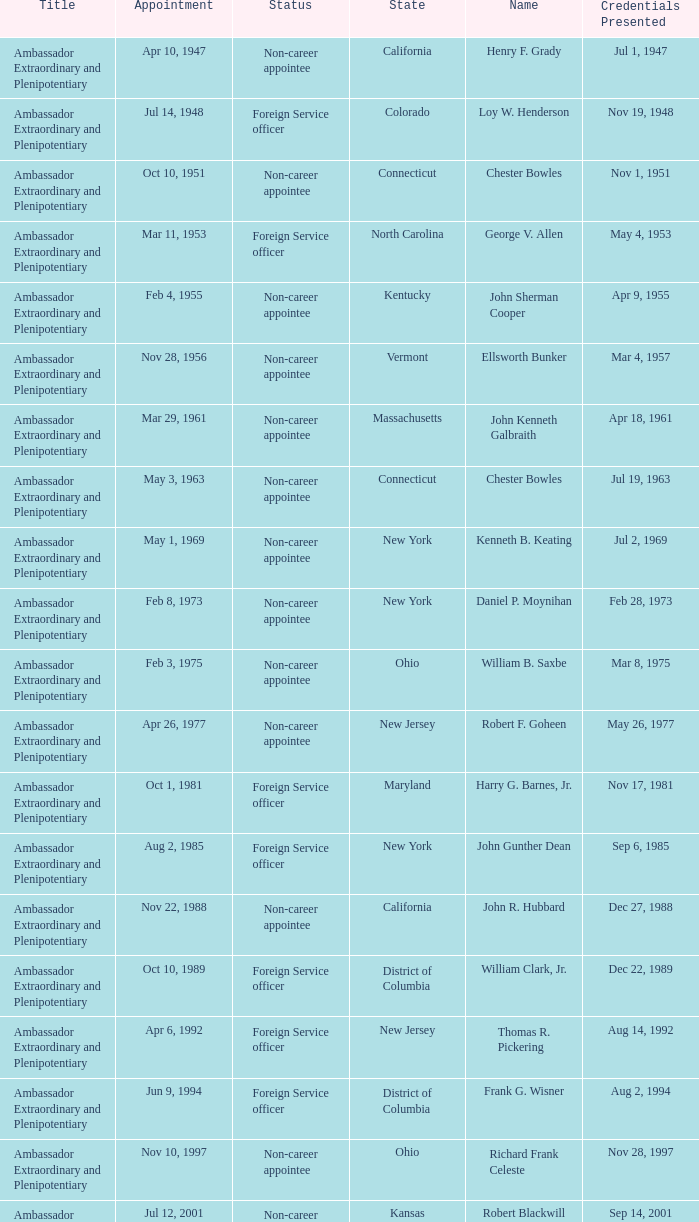What day was the appointment when Credentials Presented was jul 2, 1969? May 1, 1969. 